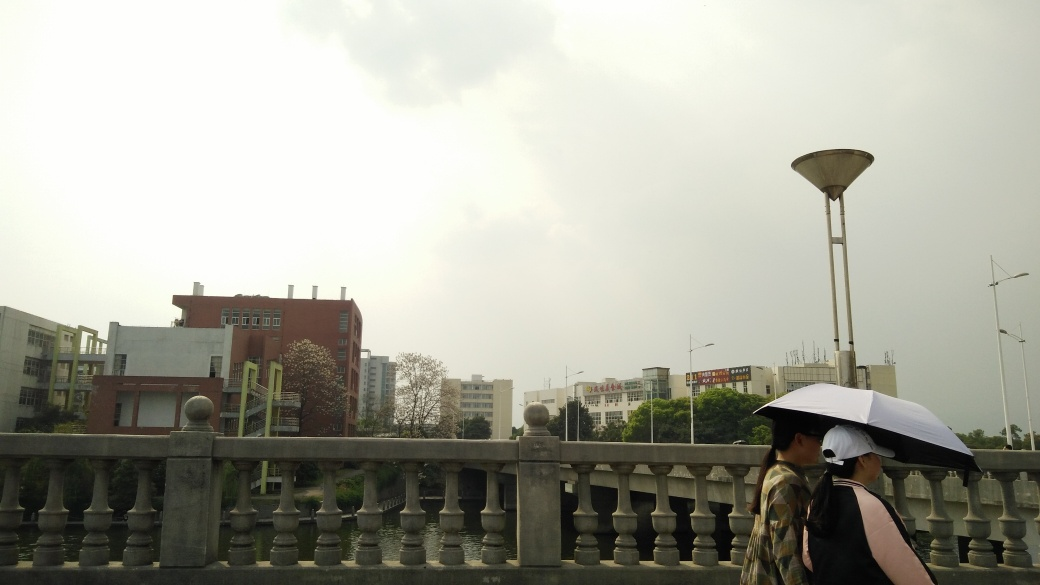Can you describe the surroundings where the two people are walking? Certainly, the two people are walking along a bridge or a walkway with a classic balustrade design. Behind them, there's a mix of urban structures, including multi-story buildings and possibly institutional or commercial properties. The presence of lamp posts indicates it's a well-traveled pedestrian area, likely in an urban setting. 